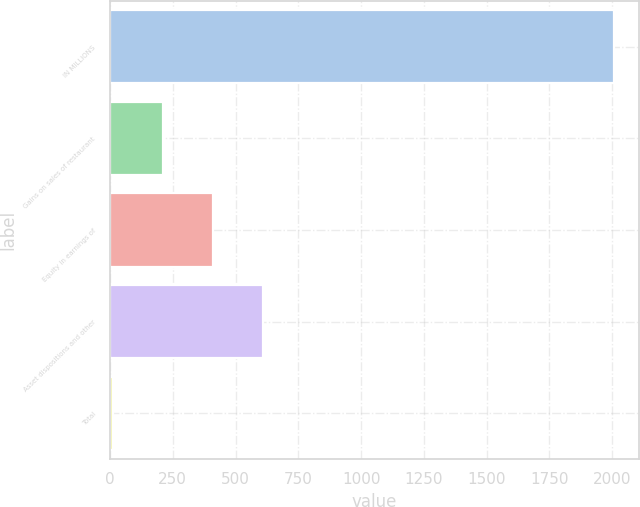Convert chart. <chart><loc_0><loc_0><loc_500><loc_500><bar_chart><fcel>IN MILLIONS<fcel>Gains on sales of restaurant<fcel>Equity in earnings of<fcel>Asset dispositions and other<fcel>Total<nl><fcel>2007<fcel>210.69<fcel>410.28<fcel>609.87<fcel>11.1<nl></chart> 